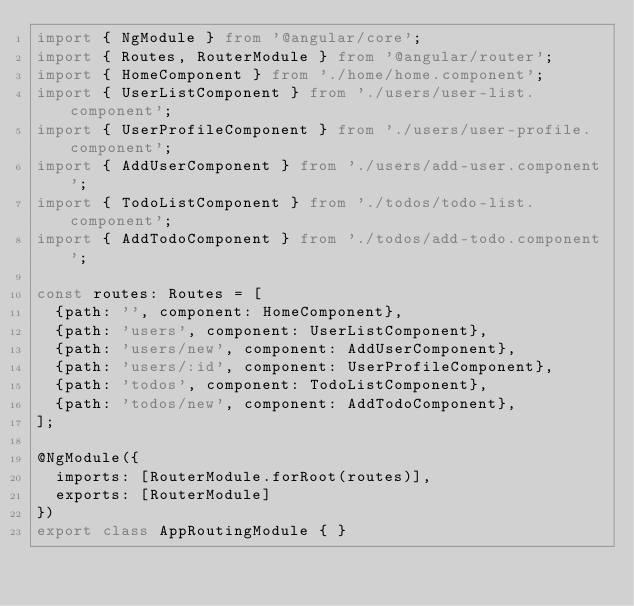<code> <loc_0><loc_0><loc_500><loc_500><_TypeScript_>import { NgModule } from '@angular/core';
import { Routes, RouterModule } from '@angular/router';
import { HomeComponent } from './home/home.component';
import { UserListComponent } from './users/user-list.component';
import { UserProfileComponent } from './users/user-profile.component';
import { AddUserComponent } from './users/add-user.component';
import { TodoListComponent } from './todos/todo-list.component';
import { AddTodoComponent } from './todos/add-todo.component';

const routes: Routes = [
  {path: '', component: HomeComponent},
  {path: 'users', component: UserListComponent},
  {path: 'users/new', component: AddUserComponent},
  {path: 'users/:id', component: UserProfileComponent},
  {path: 'todos', component: TodoListComponent},
  {path: 'todos/new', component: AddTodoComponent},
];

@NgModule({
  imports: [RouterModule.forRoot(routes)],
  exports: [RouterModule]
})
export class AppRoutingModule { }
</code> 